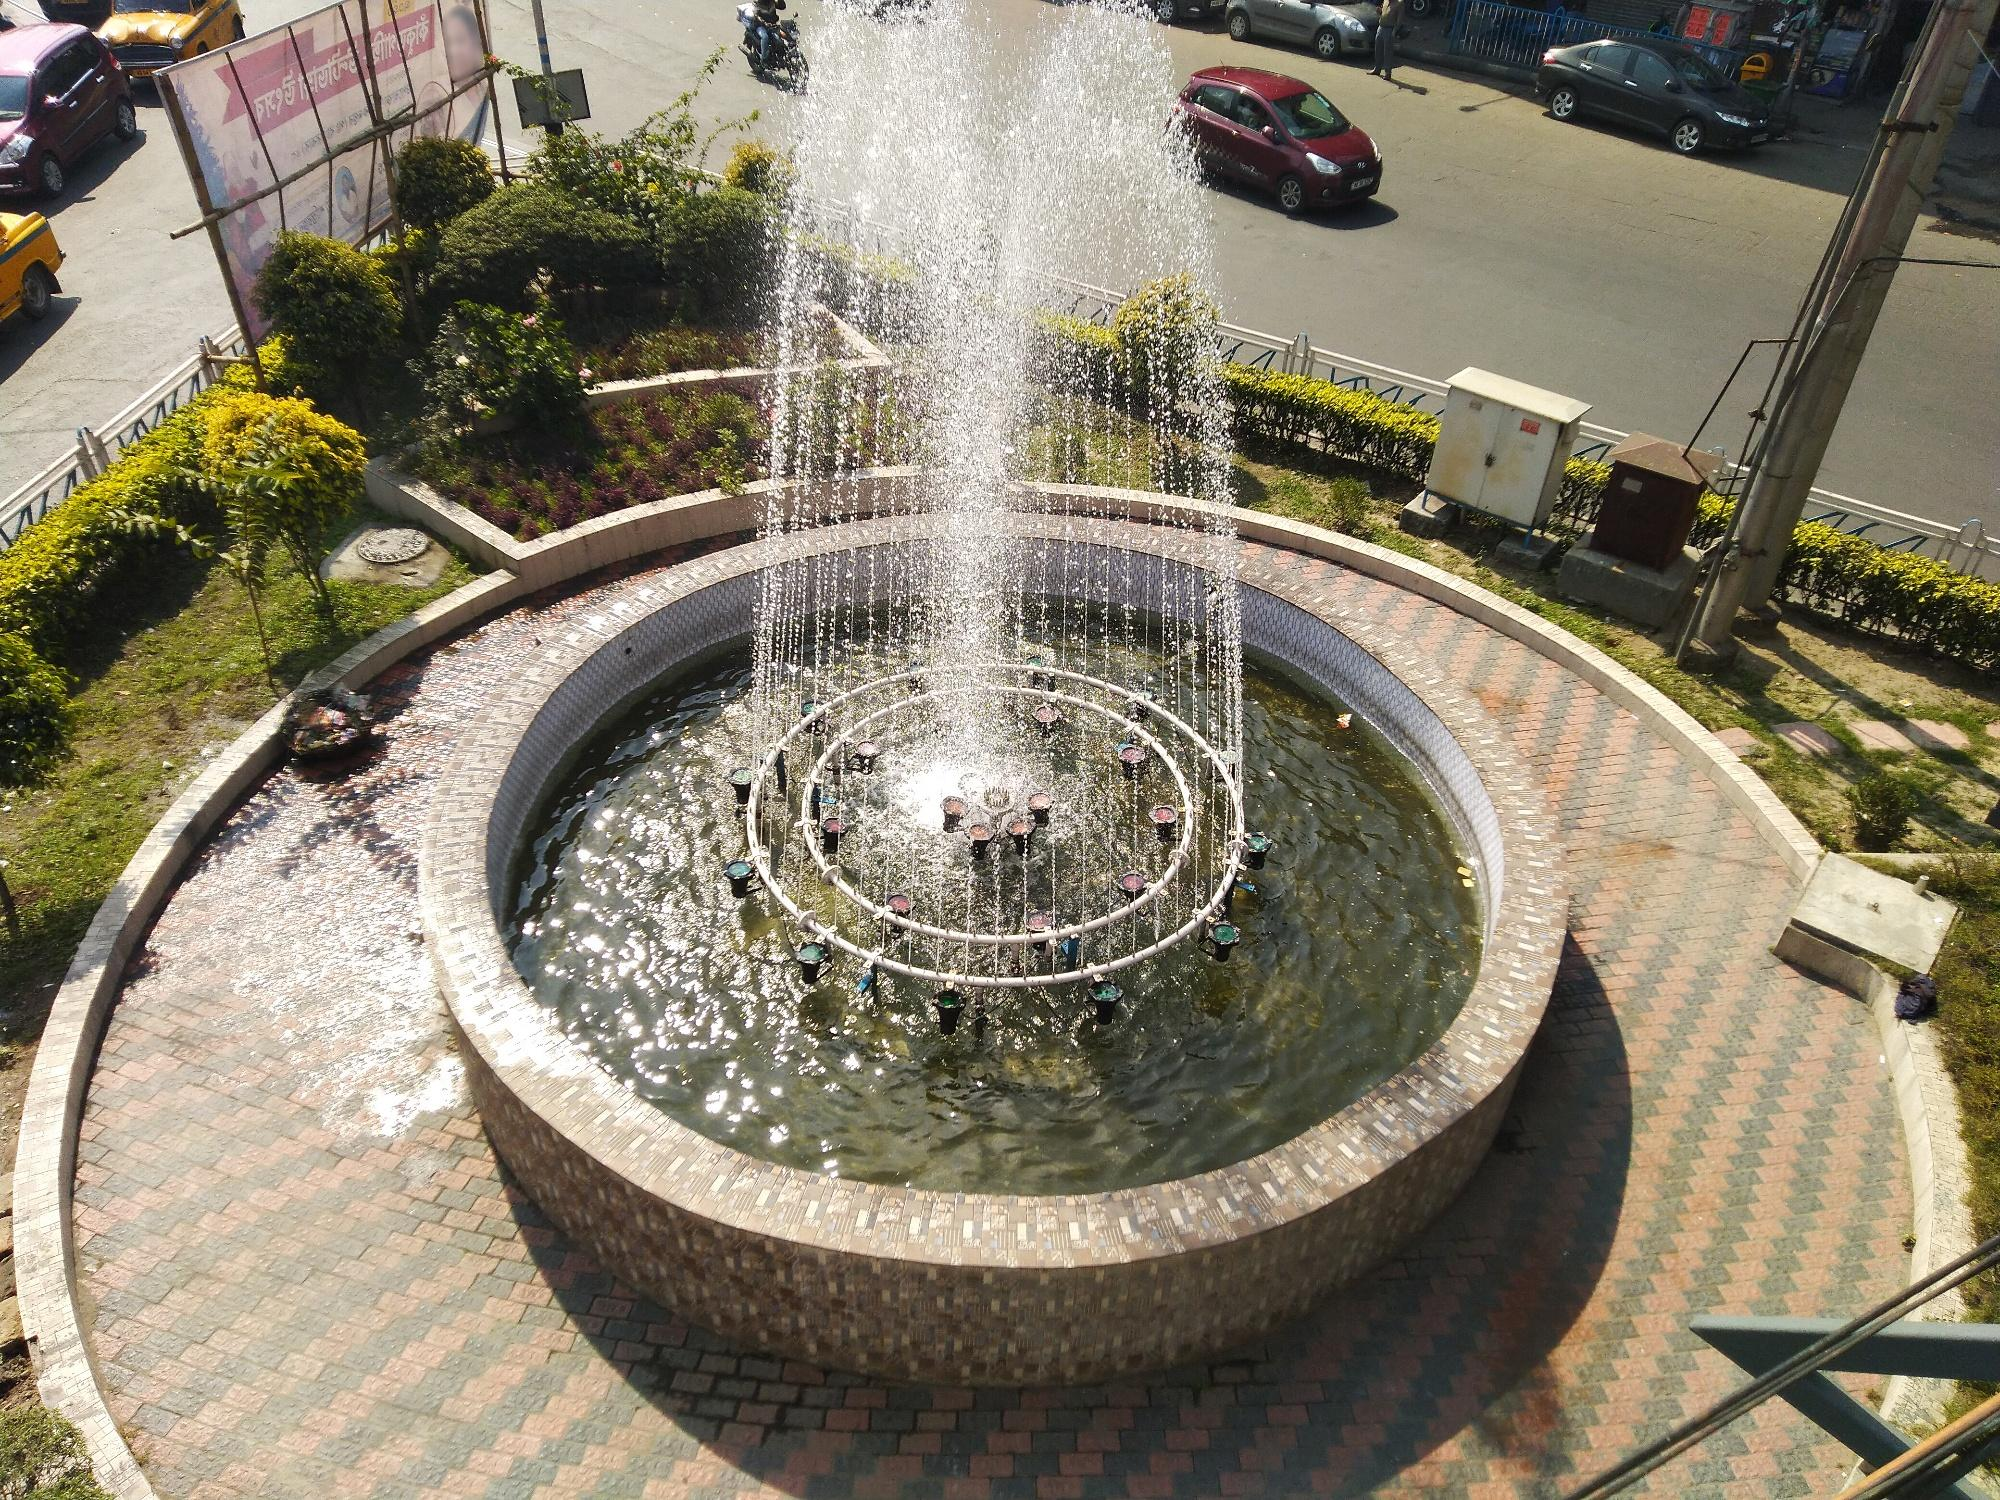What can you tell about the people who might visit this place? Visitors to this fountain could range from local residents seeking a peaceful spot to relax, tourists taking in the city's sights, to urban photographers capturing the interplay between nature and architecture. One might find people enjoying a leisurely walk, children fascinated by the water display, or artists finding inspiration in the serene, yet bustling environment. 